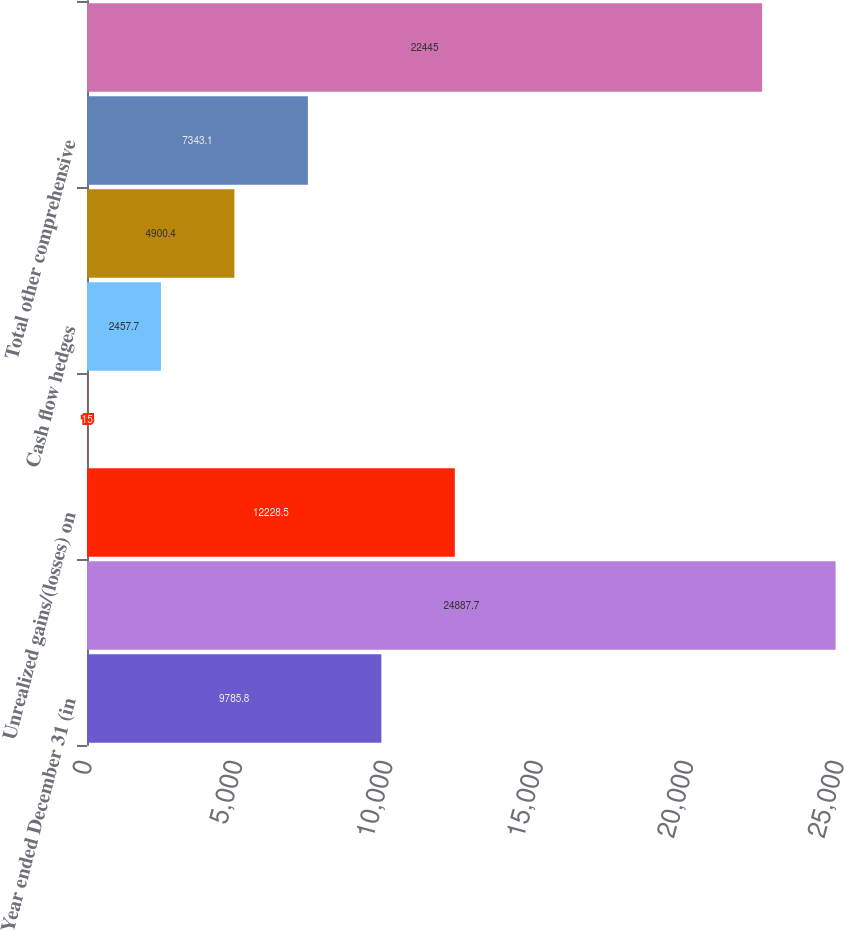Convert chart. <chart><loc_0><loc_0><loc_500><loc_500><bar_chart><fcel>Year ended December 31 (in<fcel>Net income<fcel>Unrealized gains/(losses) on<fcel>Translation adjustments net of<fcel>Cash flow hedges<fcel>Defined benefit pension and<fcel>Total other comprehensive<fcel>Comprehensive income<nl><fcel>9785.8<fcel>24887.7<fcel>12228.5<fcel>15<fcel>2457.7<fcel>4900.4<fcel>7343.1<fcel>22445<nl></chart> 